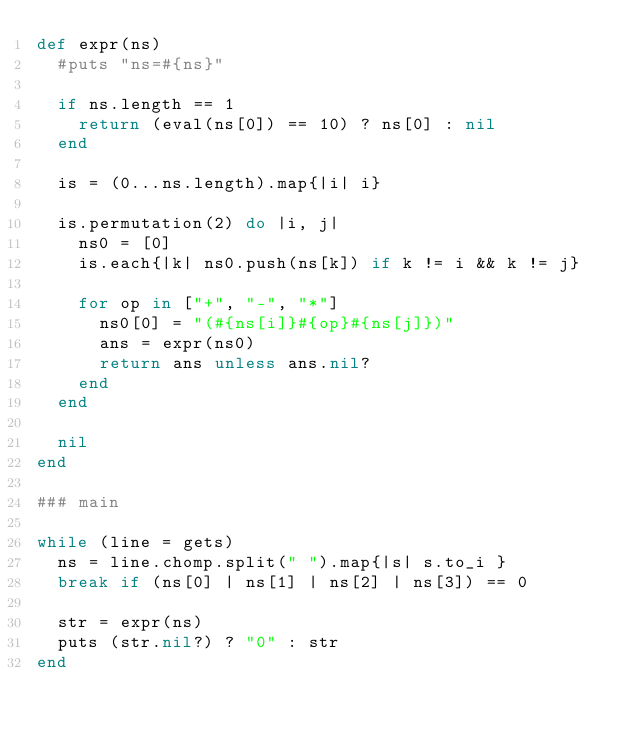<code> <loc_0><loc_0><loc_500><loc_500><_Ruby_>def expr(ns)
  #puts "ns=#{ns}"

  if ns.length == 1
    return (eval(ns[0]) == 10) ? ns[0] : nil
  end

  is = (0...ns.length).map{|i| i}

  is.permutation(2) do |i, j|
    ns0 = [0]
    is.each{|k| ns0.push(ns[k]) if k != i && k != j}

    for op in ["+", "-", "*"]
      ns0[0] = "(#{ns[i]}#{op}#{ns[j]})"
      ans = expr(ns0)
      return ans unless ans.nil?
    end
  end

  nil
end

### main

while (line = gets)
  ns = line.chomp.split(" ").map{|s| s.to_i }
  break if (ns[0] | ns[1] | ns[2] | ns[3]) == 0

  str = expr(ns)
  puts (str.nil?) ? "0" : str
end</code> 